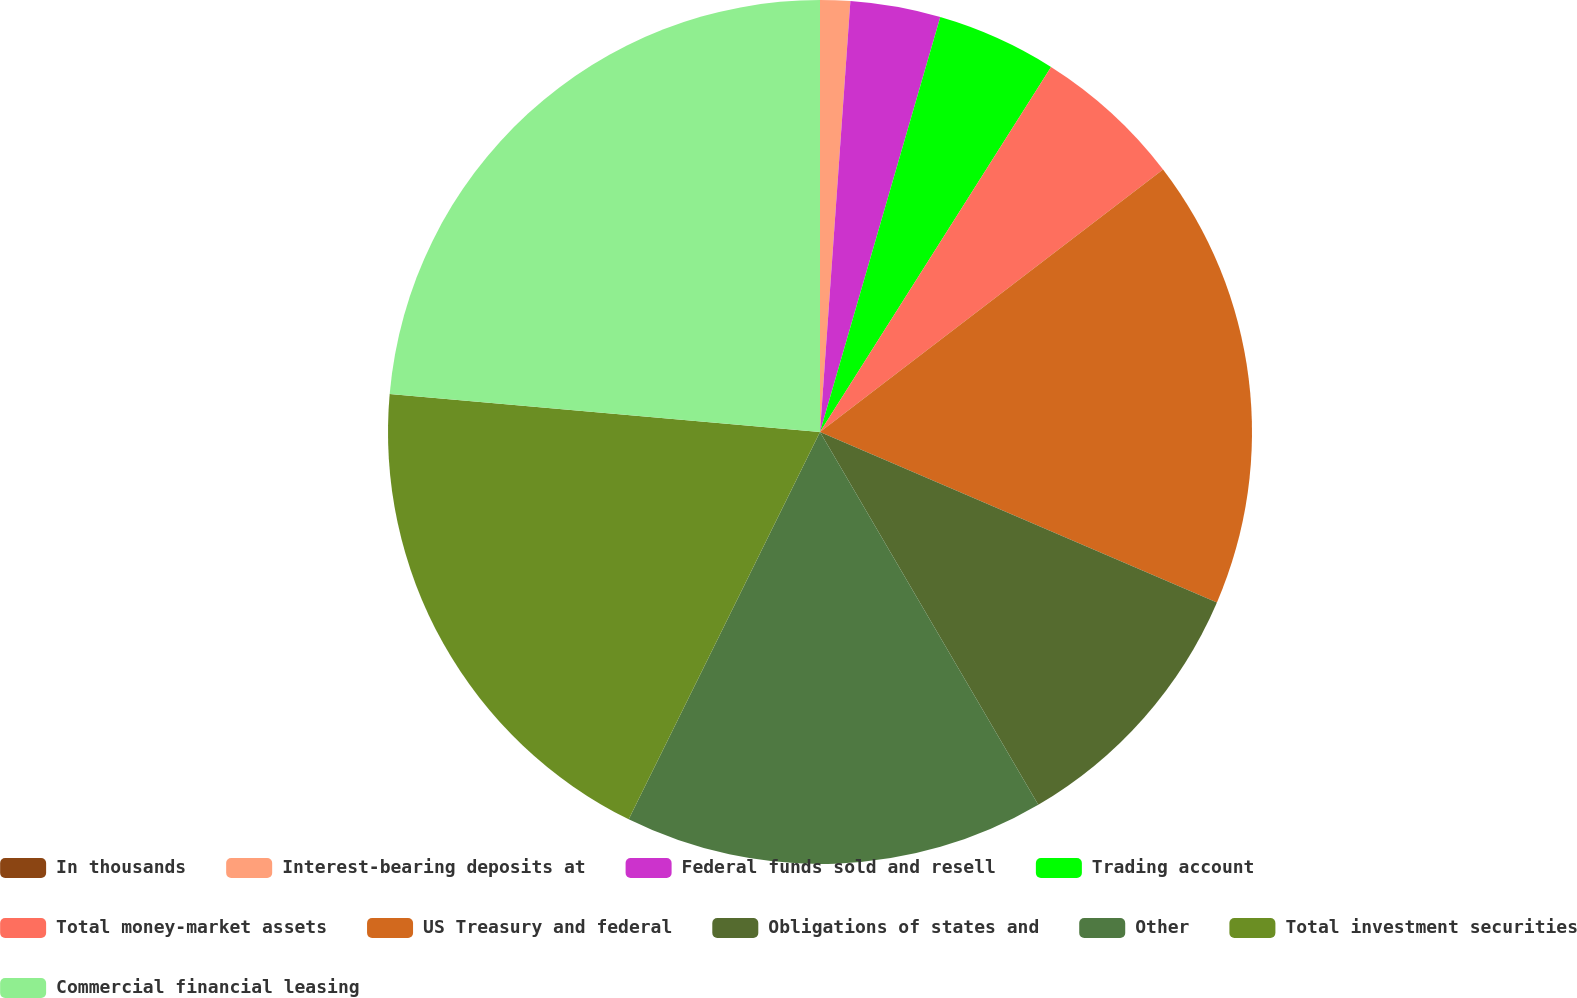Convert chart to OTSL. <chart><loc_0><loc_0><loc_500><loc_500><pie_chart><fcel>In thousands<fcel>Interest-bearing deposits at<fcel>Federal funds sold and resell<fcel>Trading account<fcel>Total money-market assets<fcel>US Treasury and federal<fcel>Obligations of states and<fcel>Other<fcel>Total investment securities<fcel>Commercial financial leasing<nl><fcel>0.0%<fcel>1.12%<fcel>3.37%<fcel>4.49%<fcel>5.62%<fcel>16.85%<fcel>10.11%<fcel>15.73%<fcel>19.1%<fcel>23.59%<nl></chart> 